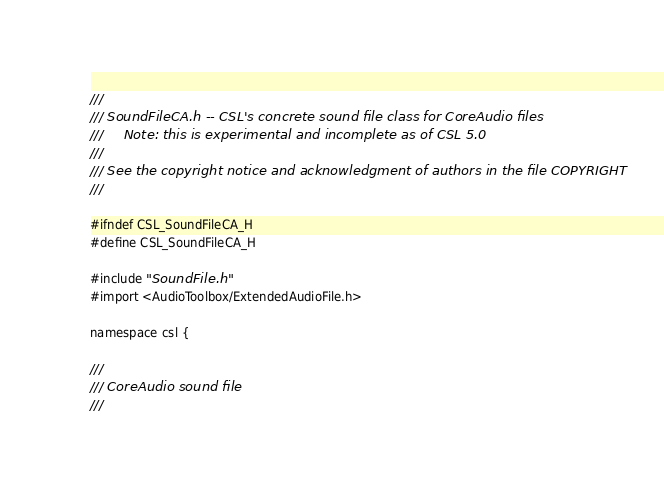Convert code to text. <code><loc_0><loc_0><loc_500><loc_500><_C_>///
/// SoundFileCA.h -- CSL's concrete sound file class for CoreAudio files
///		Note: this is experimental and incomplete as of CSL 5.0
///
///	See the copyright notice and acknowledgment of authors in the file COPYRIGHT
///

#ifndef CSL_SoundFileCA_H
#define CSL_SoundFileCA_H

#include "SoundFile.h"
#import <AudioToolbox/ExtendedAudioFile.h>

namespace csl {

///
/// CoreAudio sound file
///
</code> 